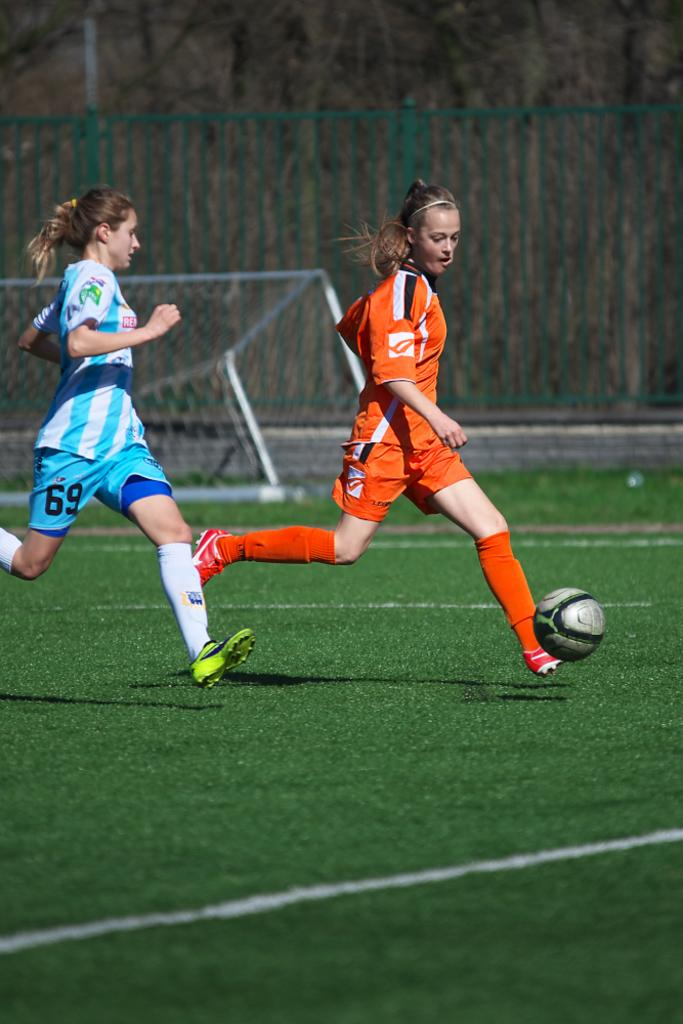How many people are present in the image? There are two girls in the image. What activity are the girls engaged in? The girls are playing football. Where is the football game taking place? The football game is taking place on a ground. What can be seen in the background of the image? There is a goal post and a fencing behind the goal post. What type of plantation can be seen in the image? There is no plantation present in the image; it features two girls playing football on a ground. 